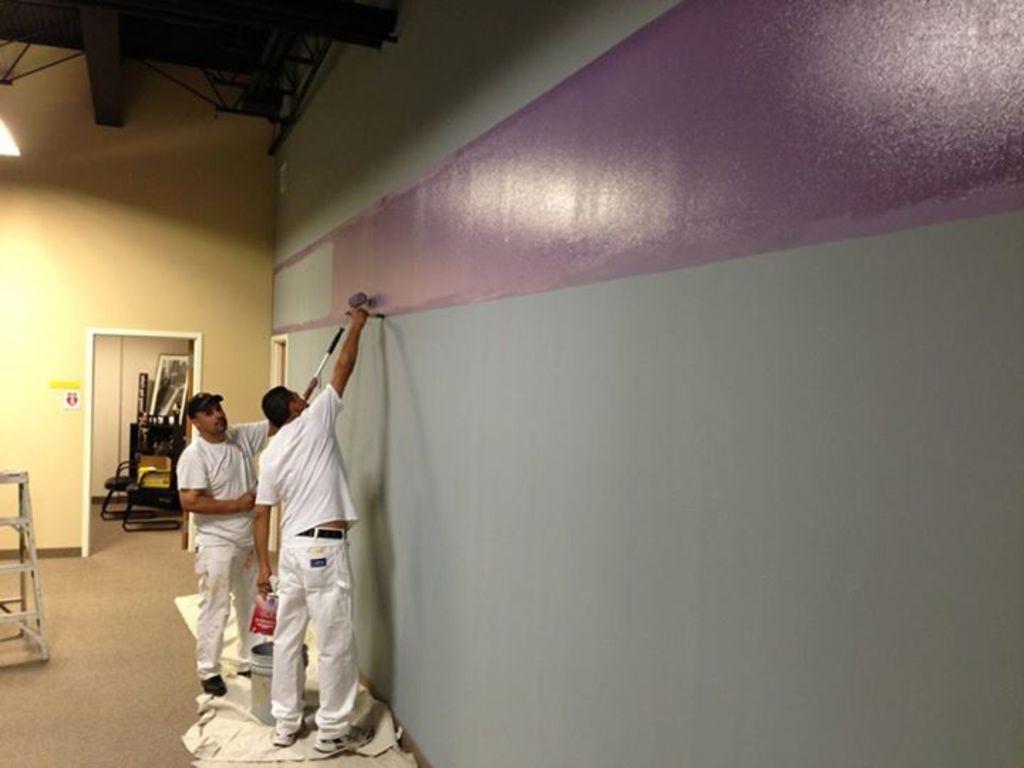Can you describe this image briefly? In this picture, we see two men are standing and they are painting the wall. Beside them, we see a bucket which is placed on the white color sheet. On the left side, we see an iron stand. In the background, we see a wall, chair and some other objects. At the top, we see the light and the roof of the building. 